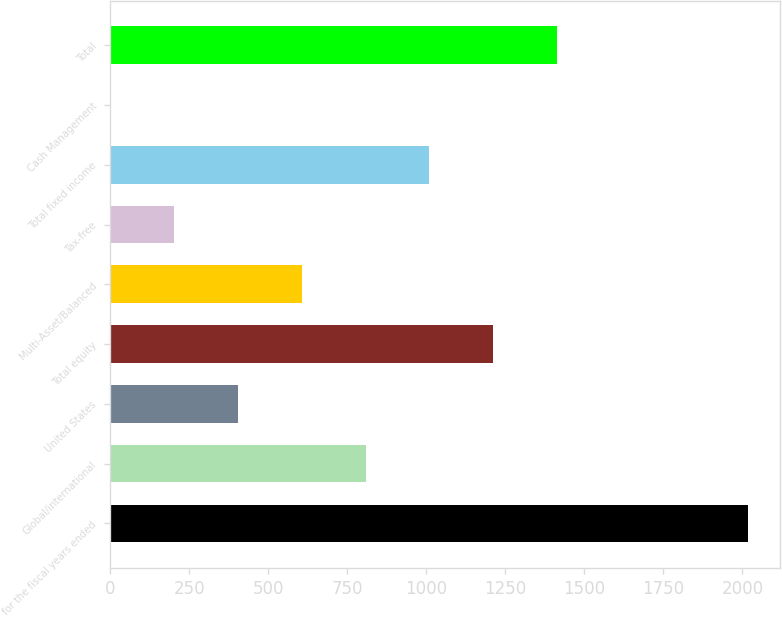Convert chart. <chart><loc_0><loc_0><loc_500><loc_500><bar_chart><fcel>for the fiscal years ended<fcel>Global/international<fcel>United States<fcel>Total equity<fcel>Multi-Asset/Balanced<fcel>Tax-free<fcel>Total fixed income<fcel>Cash Management<fcel>Total<nl><fcel>2017<fcel>807.4<fcel>404.2<fcel>1210.6<fcel>605.8<fcel>202.6<fcel>1009<fcel>1<fcel>1412.2<nl></chart> 